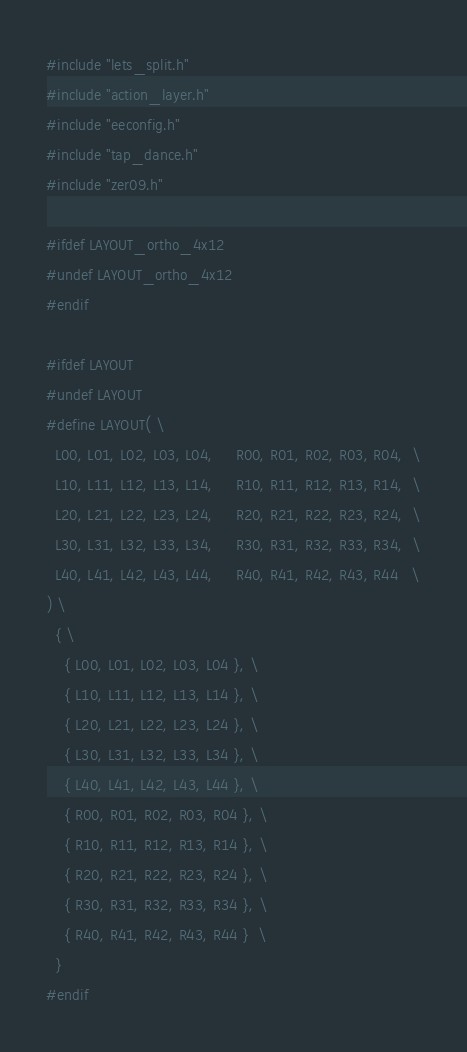Convert code to text. <code><loc_0><loc_0><loc_500><loc_500><_C_>#include "lets_split.h"
#include "action_layer.h"
#include "eeconfig.h"
#include "tap_dance.h"
#include "zer09.h"

#ifdef LAYOUT_ortho_4x12
#undef LAYOUT_ortho_4x12
#endif

#ifdef LAYOUT
#undef LAYOUT
#define LAYOUT( \
  L00, L01, L02, L03, L04,     R00, R01, R02, R03, R04,  \
  L10, L11, L12, L13, L14,     R10, R11, R12, R13, R14,  \
  L20, L21, L22, L23, L24,     R20, R21, R22, R23, R24,  \
  L30, L31, L32, L33, L34,     R30, R31, R32, R33, R34,  \
  L40, L41, L42, L43, L44,     R40, R41, R42, R43, R44   \
) \
  { \
    { L00, L01, L02, L03, L04 }, \
    { L10, L11, L12, L13, L14 }, \
    { L20, L21, L22, L23, L24 }, \
    { L30, L31, L32, L33, L34 }, \
    { L40, L41, L42, L43, L44 }, \
    { R00, R01, R02, R03, R04 }, \
    { R10, R11, R12, R13, R14 }, \
    { R20, R21, R22, R23, R24 }, \
    { R30, R31, R32, R33, R34 }, \
    { R40, R41, R42, R43, R44 }  \
  }
#endif
</code> 